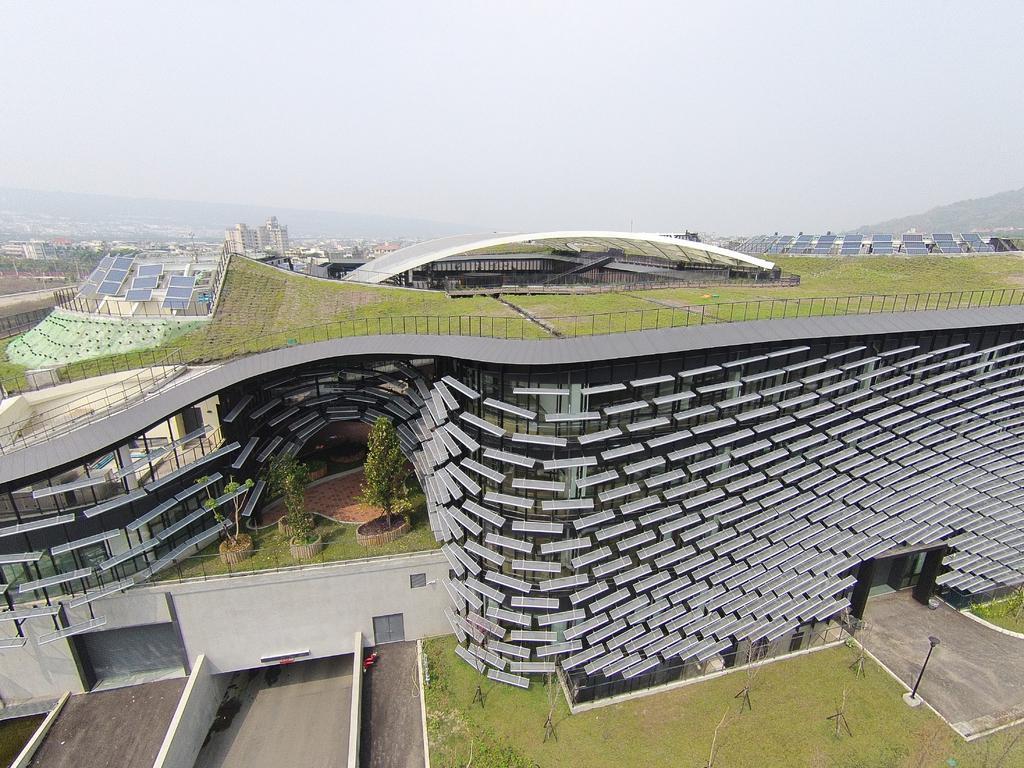Could you give a brief overview of what you see in this image? In this image we can see the buildings with solar lights and there are trees, grass, ground and pole. At the top we can see the sky. 